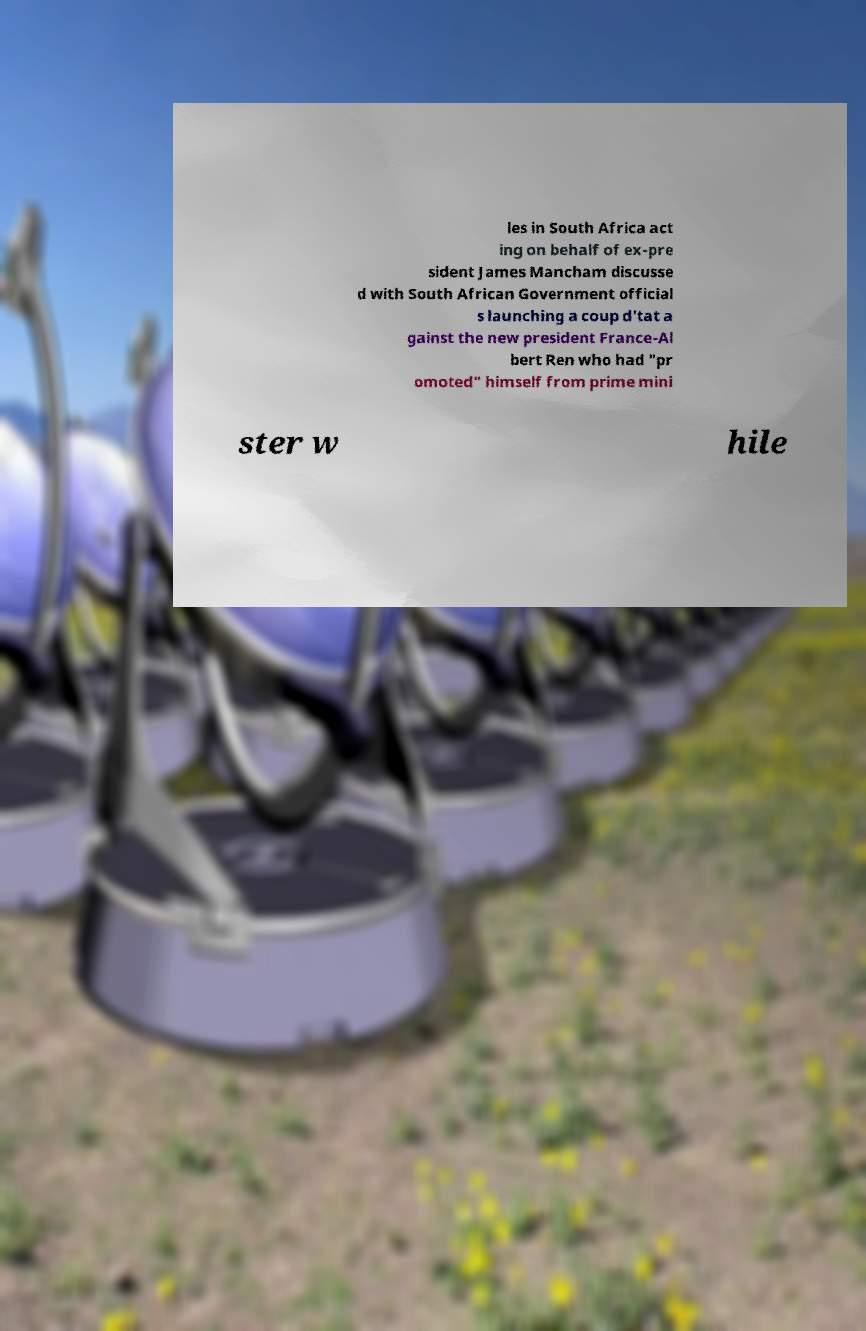Please read and relay the text visible in this image. What does it say? les in South Africa act ing on behalf of ex-pre sident James Mancham discusse d with South African Government official s launching a coup d'tat a gainst the new president France-Al bert Ren who had "pr omoted" himself from prime mini ster w hile 